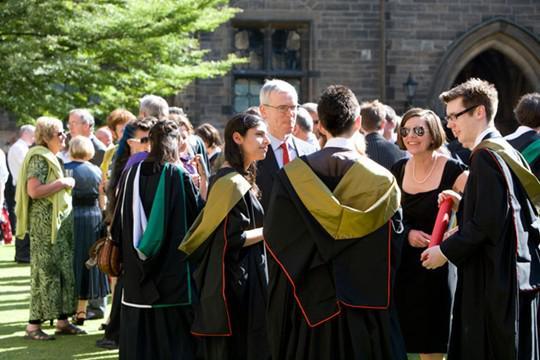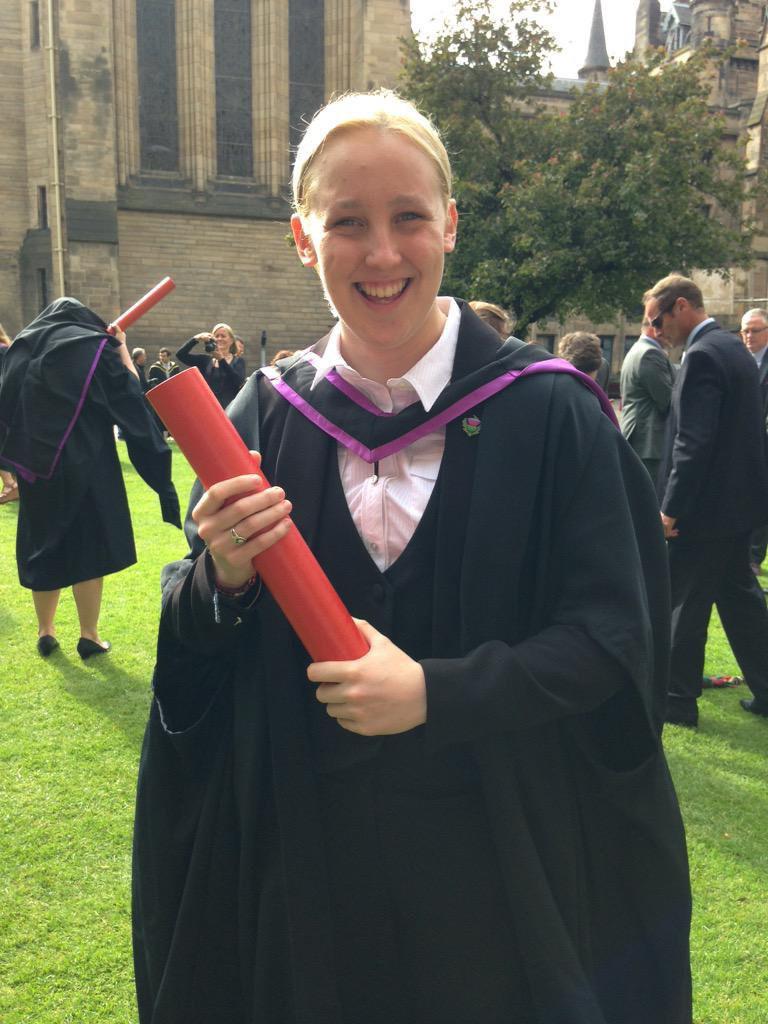The first image is the image on the left, the second image is the image on the right. Assess this claim about the two images: "Right image shows multiple graduates holding red rolled items, and includes a fellow in a kilt.". Correct or not? Answer yes or no. No. The first image is the image on the left, the second image is the image on the right. For the images shown, is this caption "In each image, at least one black-robed graduate is holding a diploma in a red tube, while standing in front of a large stone building." true? Answer yes or no. Yes. 